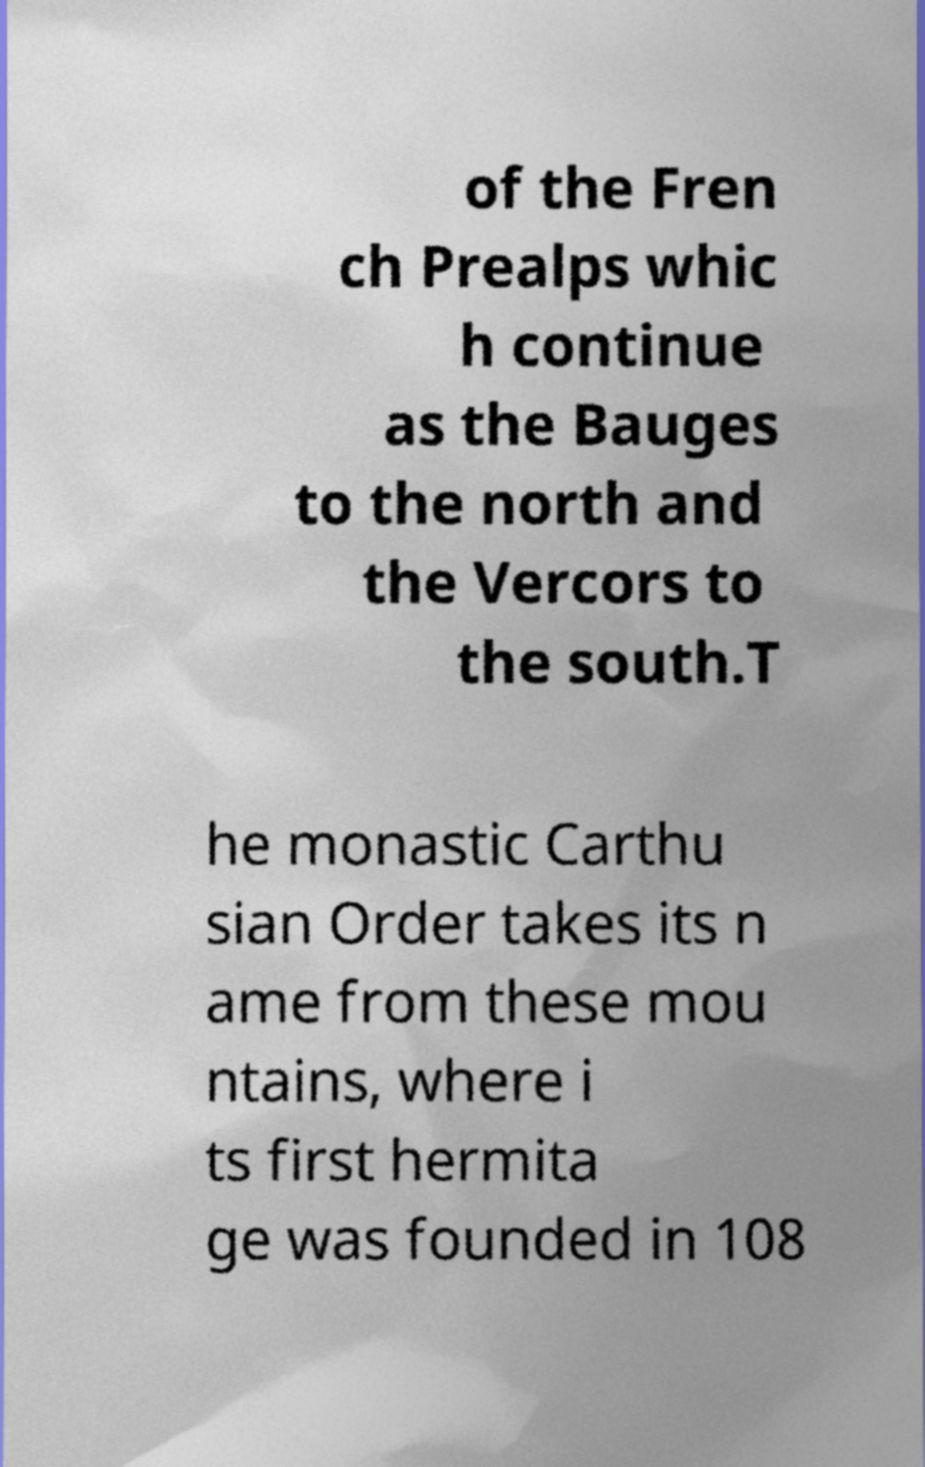Can you accurately transcribe the text from the provided image for me? of the Fren ch Prealps whic h continue as the Bauges to the north and the Vercors to the south.T he monastic Carthu sian Order takes its n ame from these mou ntains, where i ts first hermita ge was founded in 108 